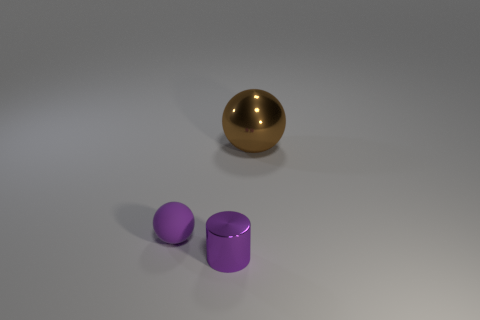Add 1 large rubber spheres. How many objects exist? 4 Subtract all spheres. How many objects are left? 1 Subtract 0 red cubes. How many objects are left? 3 Subtract all cylinders. Subtract all blue balls. How many objects are left? 2 Add 3 tiny purple spheres. How many tiny purple spheres are left? 4 Add 2 large brown spheres. How many large brown spheres exist? 3 